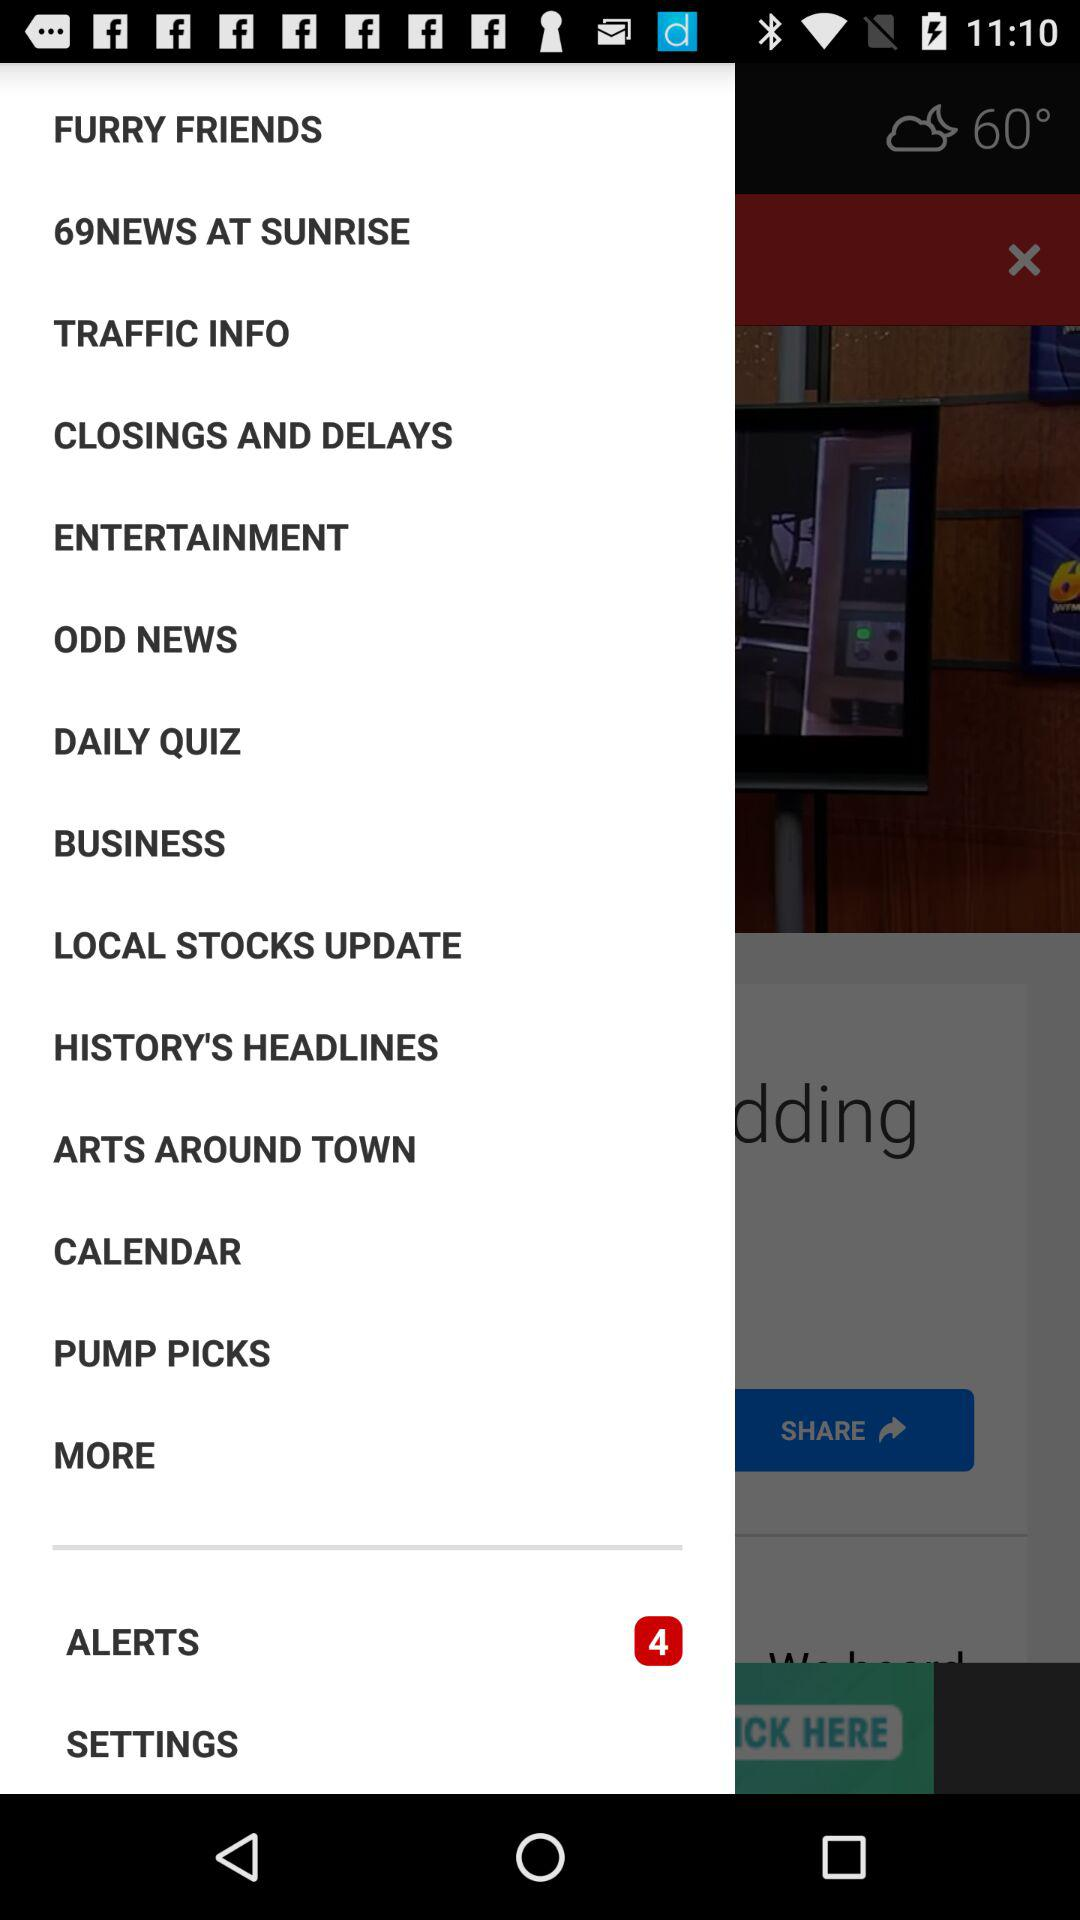How many alert notifications are there? There are 4 alert notifications. 